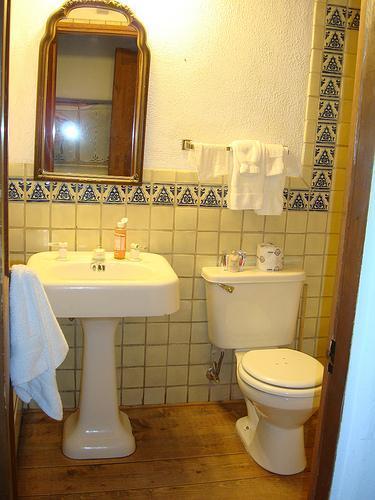How many mirrors are in the photo?
Give a very brief answer. 1. How many towels are in the photo?
Give a very brief answer. 3. How many wash rags are in the scene?
Give a very brief answer. 3. How many sinks are in the picture?
Give a very brief answer. 1. 